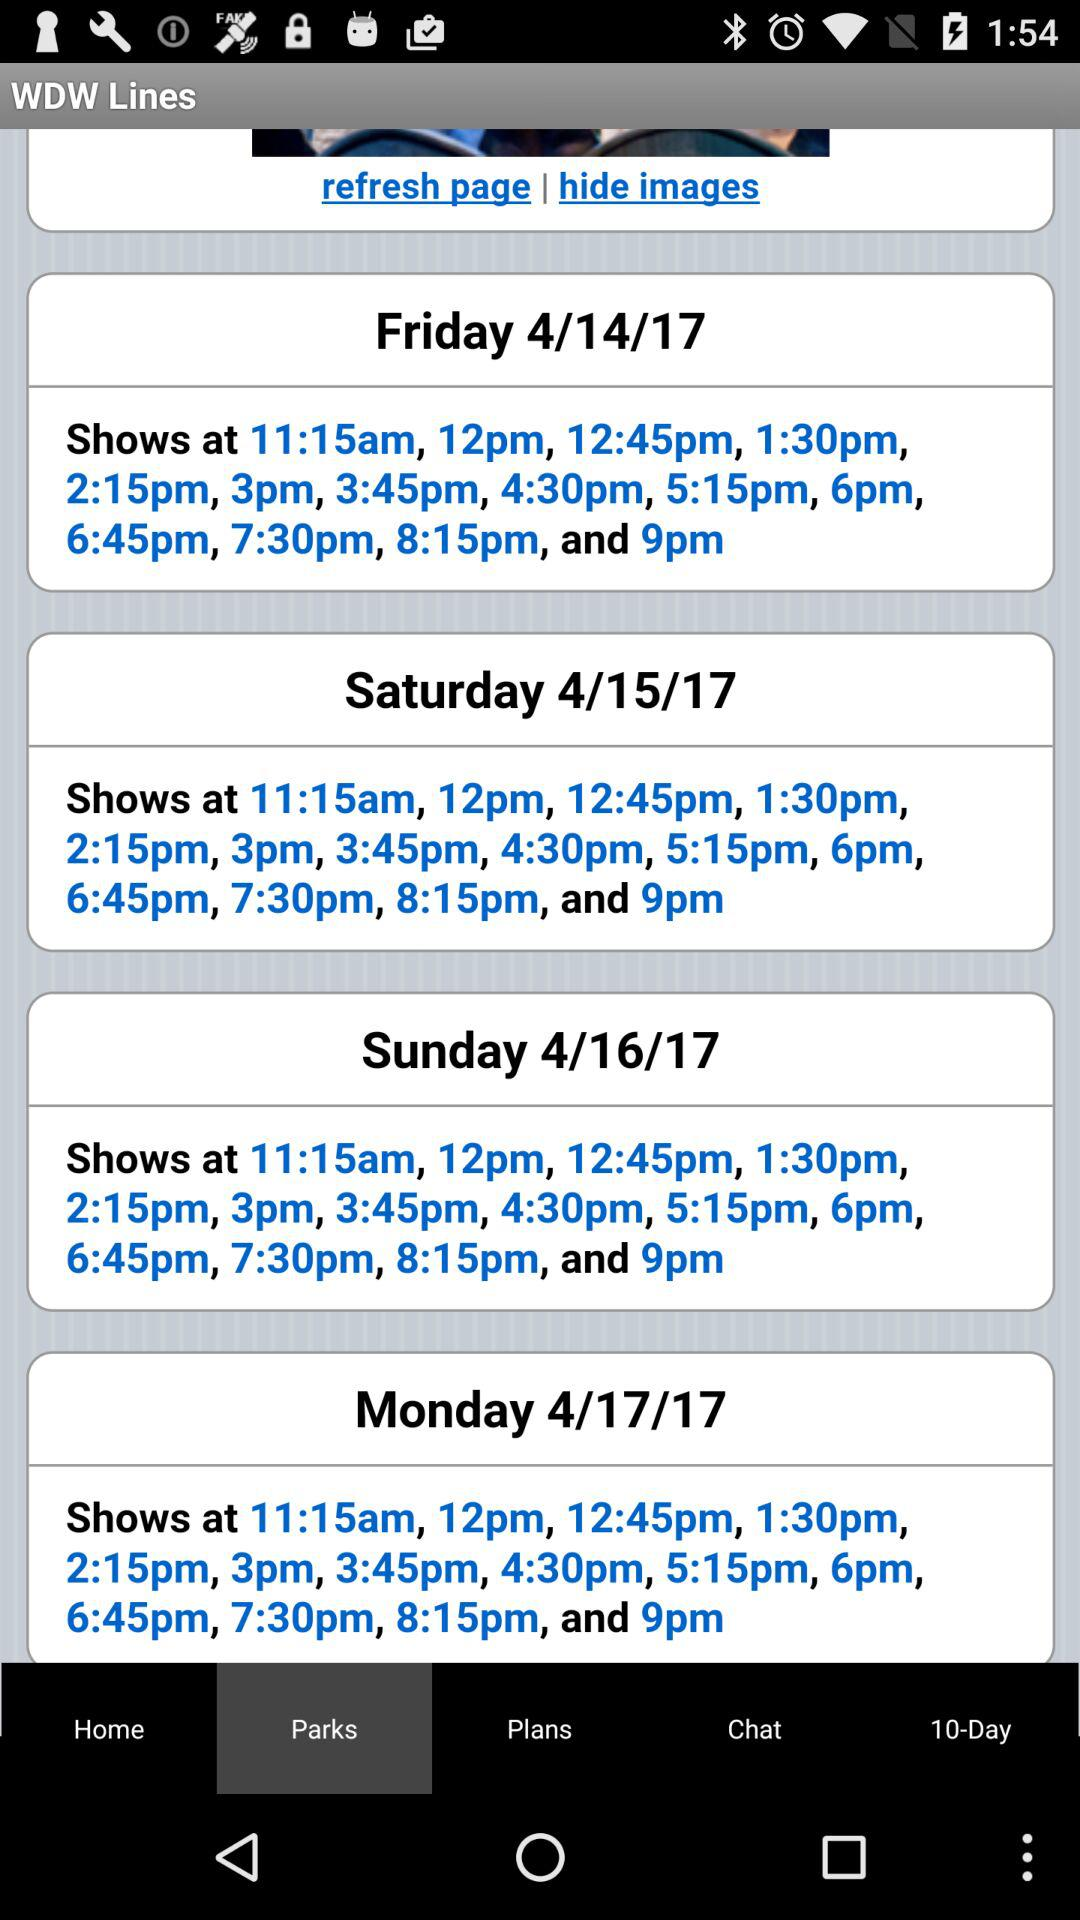What is the date on Saturday? The date is April 15, 2017. 